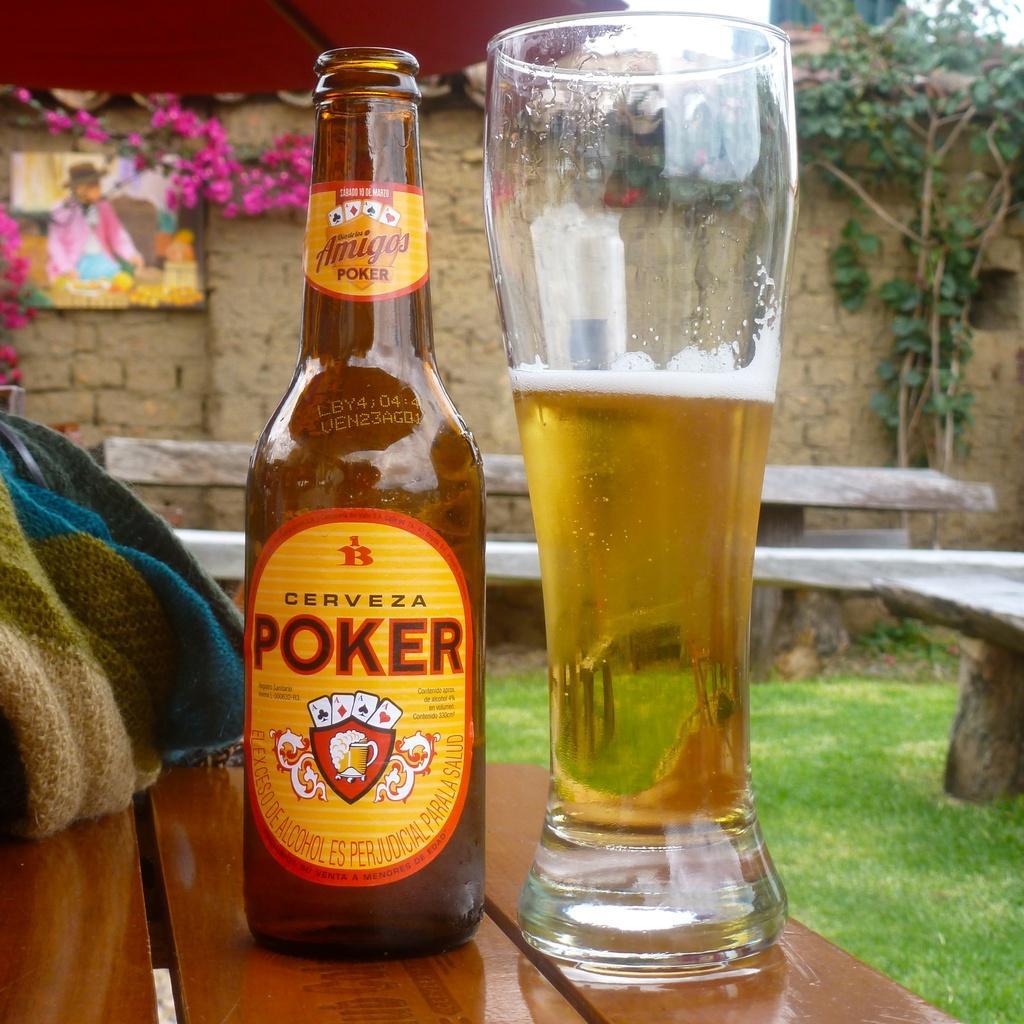Please provide a concise description of this image. There is a beer bottle and a beer glass on the table and the right side of an image there is a tree behind that there is a tree. left side of an image there is an art and flowers. 